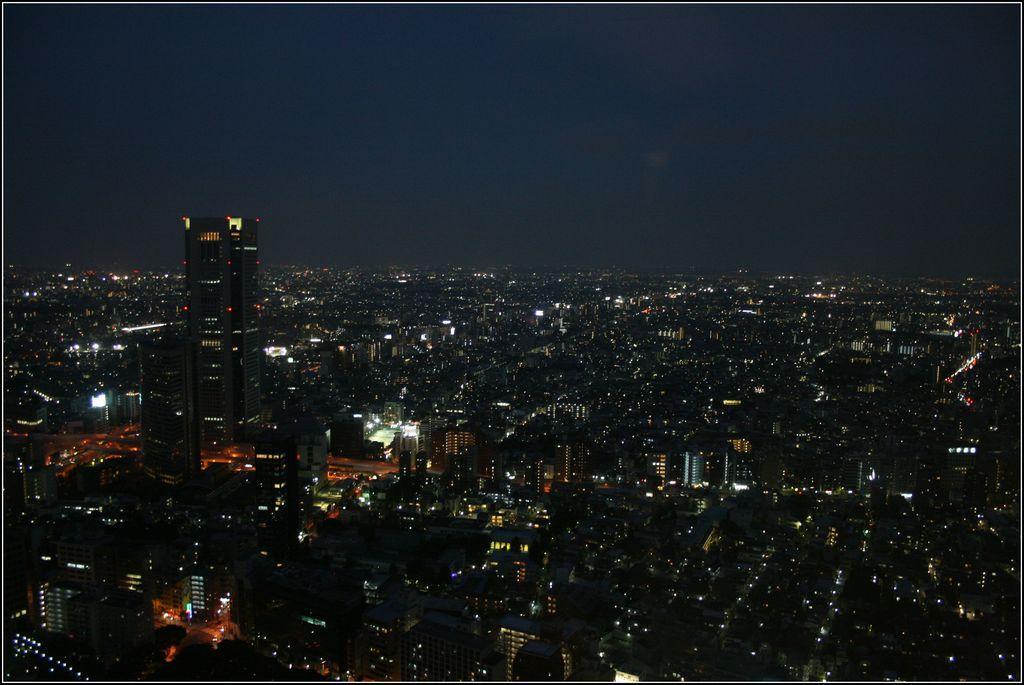Could you give a brief overview of what you see in this image? This picture is clicked outside the city. In the foreground we can see many number of buildings, lights and some skyscrapers. In the background there is a sky. 